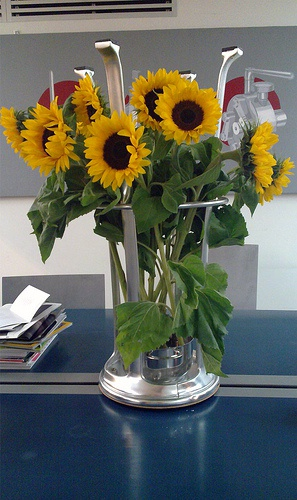Describe the objects in this image and their specific colors. I can see potted plant in gray, black, and darkgreen tones, vase in gray, white, and darkgray tones, vase in gray and lightgray tones, vase in gray and black tones, and book in gray, black, and darkgreen tones in this image. 